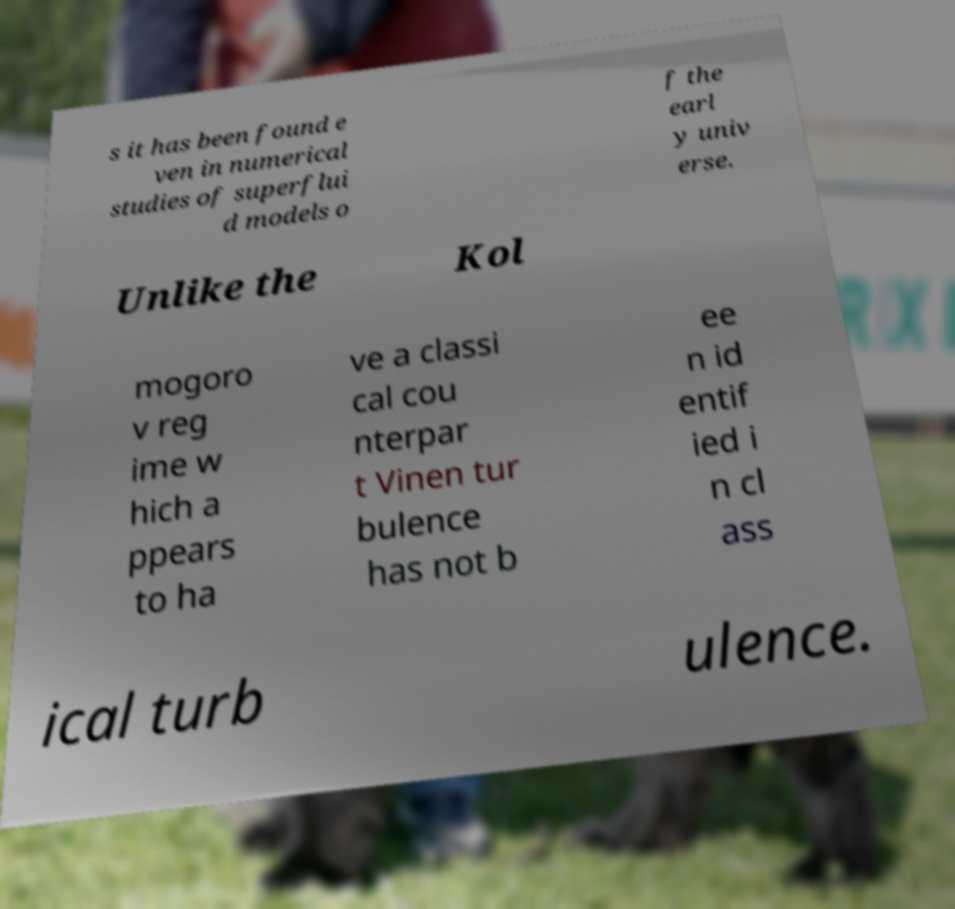Please identify and transcribe the text found in this image. s it has been found e ven in numerical studies of superflui d models o f the earl y univ erse. Unlike the Kol mogoro v reg ime w hich a ppears to ha ve a classi cal cou nterpar t Vinen tur bulence has not b ee n id entif ied i n cl ass ical turb ulence. 